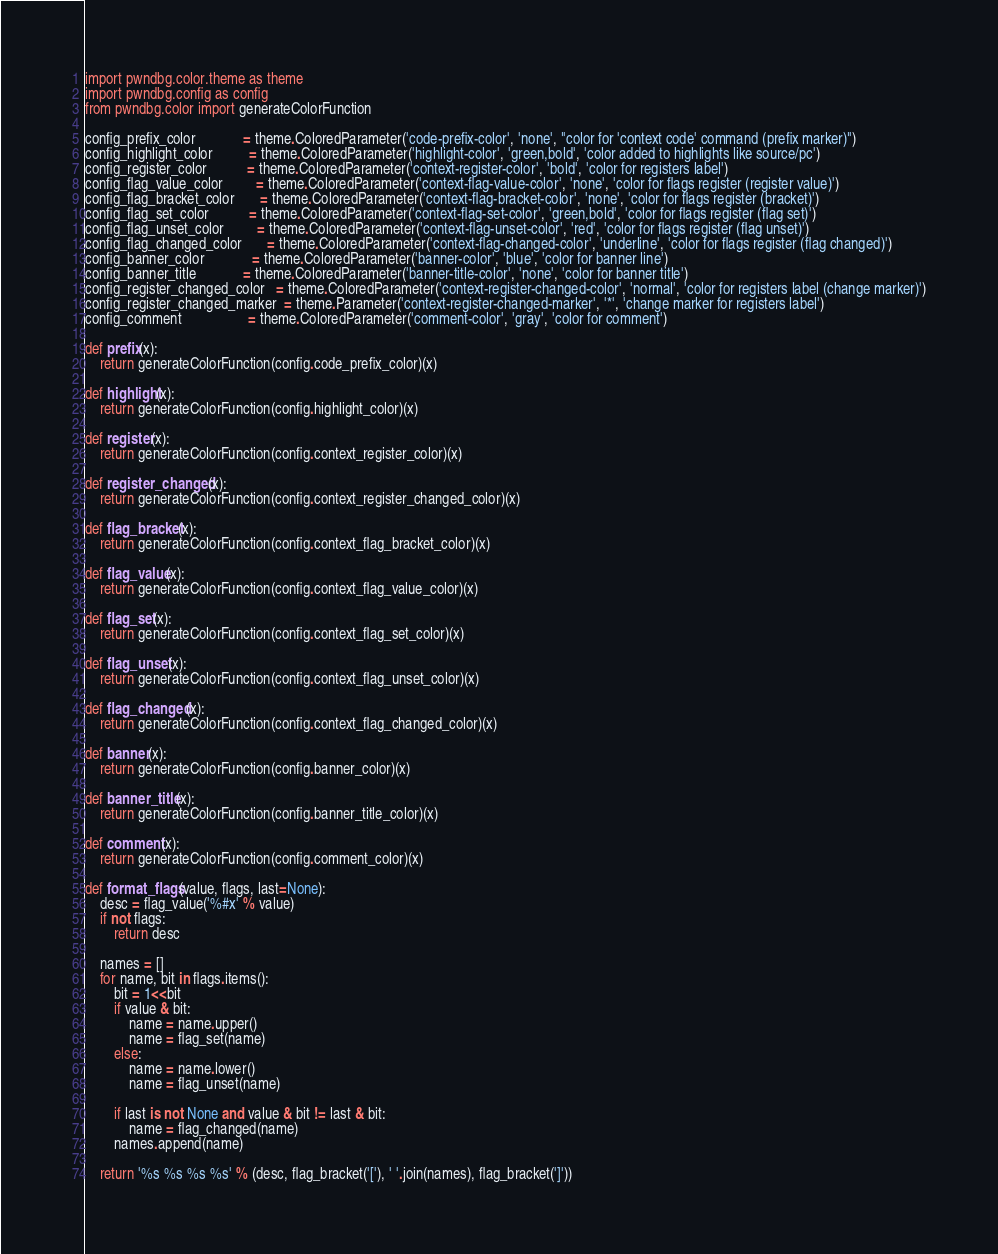Convert code to text. <code><loc_0><loc_0><loc_500><loc_500><_Python_>import pwndbg.color.theme as theme
import pwndbg.config as config
from pwndbg.color import generateColorFunction

config_prefix_color             = theme.ColoredParameter('code-prefix-color', 'none', "color for 'context code' command (prefix marker)")
config_highlight_color          = theme.ColoredParameter('highlight-color', 'green,bold', 'color added to highlights like source/pc')
config_register_color           = theme.ColoredParameter('context-register-color', 'bold', 'color for registers label')
config_flag_value_color         = theme.ColoredParameter('context-flag-value-color', 'none', 'color for flags register (register value)')
config_flag_bracket_color       = theme.ColoredParameter('context-flag-bracket-color', 'none', 'color for flags register (bracket)')
config_flag_set_color           = theme.ColoredParameter('context-flag-set-color', 'green,bold', 'color for flags register (flag set)')
config_flag_unset_color         = theme.ColoredParameter('context-flag-unset-color', 'red', 'color for flags register (flag unset)')
config_flag_changed_color       = theme.ColoredParameter('context-flag-changed-color', 'underline', 'color for flags register (flag changed)')
config_banner_color             = theme.ColoredParameter('banner-color', 'blue', 'color for banner line')
config_banner_title             = theme.ColoredParameter('banner-title-color', 'none', 'color for banner title')
config_register_changed_color   = theme.ColoredParameter('context-register-changed-color', 'normal', 'color for registers label (change marker)')
config_register_changed_marker  = theme.Parameter('context-register-changed-marker', '*', 'change marker for registers label')
config_comment                  = theme.ColoredParameter('comment-color', 'gray', 'color for comment')

def prefix(x):
    return generateColorFunction(config.code_prefix_color)(x)

def highlight(x):
    return generateColorFunction(config.highlight_color)(x)

def register(x):
    return generateColorFunction(config.context_register_color)(x)

def register_changed(x):
    return generateColorFunction(config.context_register_changed_color)(x)

def flag_bracket(x):
    return generateColorFunction(config.context_flag_bracket_color)(x)

def flag_value(x):
    return generateColorFunction(config.context_flag_value_color)(x)

def flag_set(x):
    return generateColorFunction(config.context_flag_set_color)(x)

def flag_unset(x):
    return generateColorFunction(config.context_flag_unset_color)(x)

def flag_changed(x):
    return generateColorFunction(config.context_flag_changed_color)(x)

def banner(x):
    return generateColorFunction(config.banner_color)(x)

def banner_title(x):
    return generateColorFunction(config.banner_title_color)(x)

def comment(x):
    return generateColorFunction(config.comment_color)(x)

def format_flags(value, flags, last=None):
    desc = flag_value('%#x' % value)
    if not flags:
        return desc

    names = []
    for name, bit in flags.items():
        bit = 1<<bit
        if value & bit:
            name = name.upper()
            name = flag_set(name)
        else:
            name = name.lower()
            name = flag_unset(name)

        if last is not None and value & bit != last & bit:
            name = flag_changed(name)
        names.append(name)

    return '%s %s %s %s' % (desc, flag_bracket('['), ' '.join(names), flag_bracket(']'))

</code> 